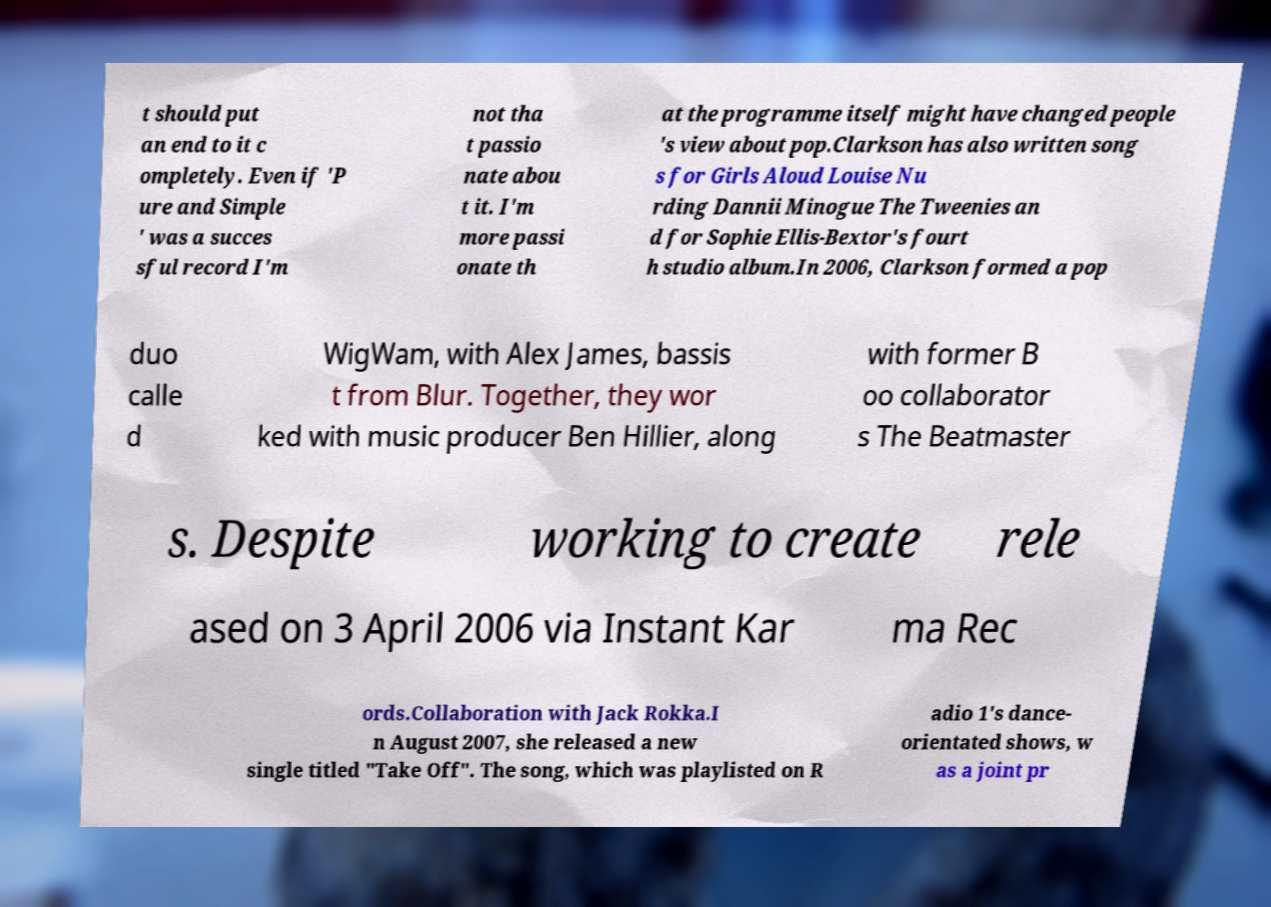There's text embedded in this image that I need extracted. Can you transcribe it verbatim? t should put an end to it c ompletely. Even if 'P ure and Simple ' was a succes sful record I'm not tha t passio nate abou t it. I'm more passi onate th at the programme itself might have changed people 's view about pop.Clarkson has also written song s for Girls Aloud Louise Nu rding Dannii Minogue The Tweenies an d for Sophie Ellis-Bextor's fourt h studio album.In 2006, Clarkson formed a pop duo calle d WigWam, with Alex James, bassis t from Blur. Together, they wor ked with music producer Ben Hillier, along with former B oo collaborator s The Beatmaster s. Despite working to create rele ased on 3 April 2006 via Instant Kar ma Rec ords.Collaboration with Jack Rokka.I n August 2007, she released a new single titled "Take Off". The song, which was playlisted on R adio 1's dance- orientated shows, w as a joint pr 